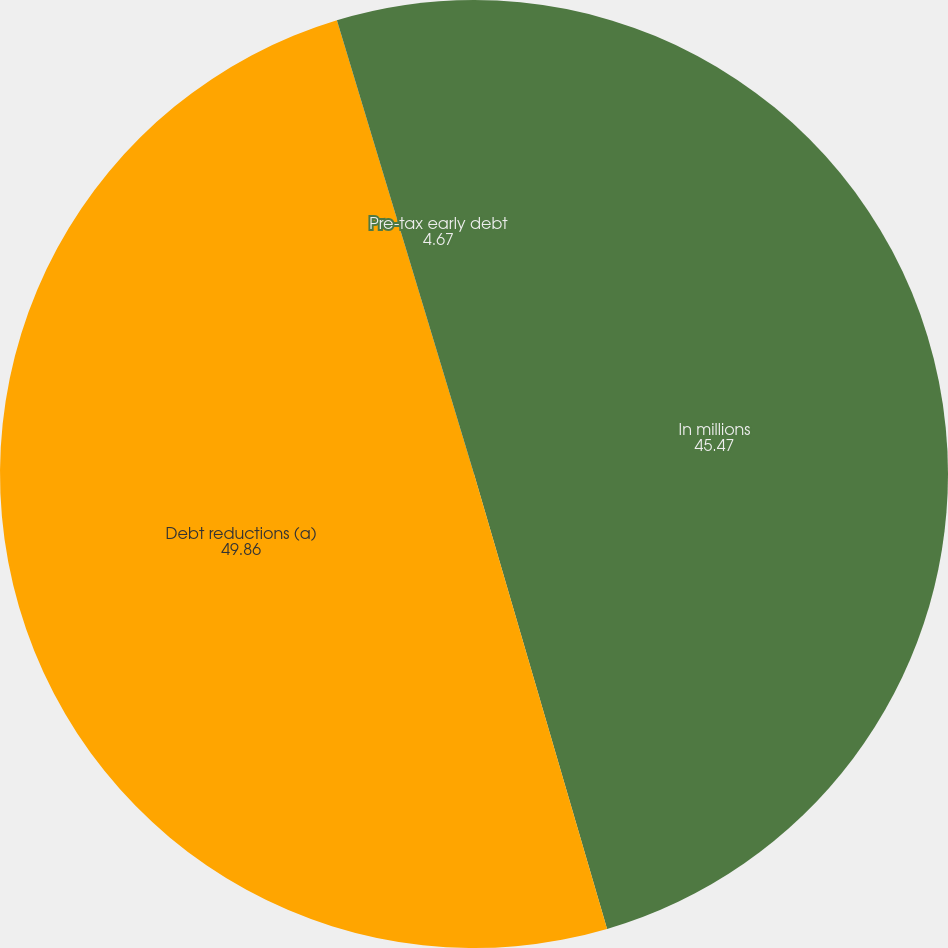Convert chart. <chart><loc_0><loc_0><loc_500><loc_500><pie_chart><fcel>In millions<fcel>Debt reductions (a)<fcel>Pre-tax early debt<nl><fcel>45.47%<fcel>49.86%<fcel>4.67%<nl></chart> 